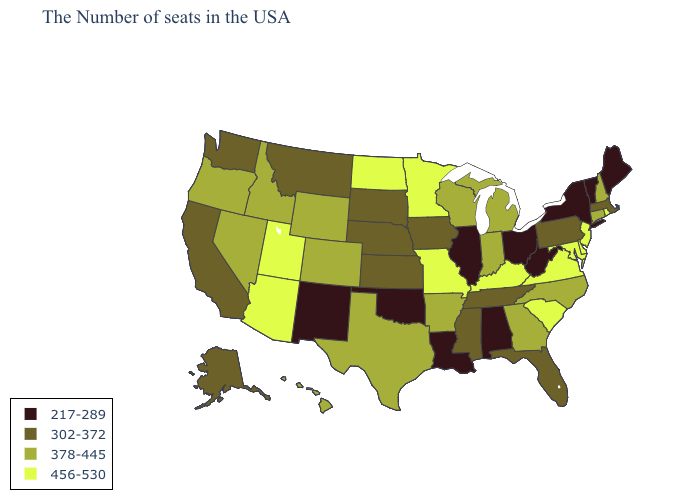Among the states that border South Carolina , which have the highest value?
Keep it brief. North Carolina, Georgia. What is the value of Oregon?
Write a very short answer. 378-445. Name the states that have a value in the range 302-372?
Short answer required. Massachusetts, Pennsylvania, Florida, Tennessee, Mississippi, Iowa, Kansas, Nebraska, South Dakota, Montana, California, Washington, Alaska. Which states have the highest value in the USA?
Short answer required. Rhode Island, New Jersey, Delaware, Maryland, Virginia, South Carolina, Kentucky, Missouri, Minnesota, North Dakota, Utah, Arizona. Does Missouri have the highest value in the USA?
Give a very brief answer. Yes. What is the value of Tennessee?
Give a very brief answer. 302-372. What is the value of California?
Write a very short answer. 302-372. Name the states that have a value in the range 378-445?
Give a very brief answer. New Hampshire, Connecticut, North Carolina, Georgia, Michigan, Indiana, Wisconsin, Arkansas, Texas, Wyoming, Colorado, Idaho, Nevada, Oregon, Hawaii. Does the map have missing data?
Short answer required. No. What is the value of Washington?
Quick response, please. 302-372. Name the states that have a value in the range 456-530?
Write a very short answer. Rhode Island, New Jersey, Delaware, Maryland, Virginia, South Carolina, Kentucky, Missouri, Minnesota, North Dakota, Utah, Arizona. Which states have the highest value in the USA?
Short answer required. Rhode Island, New Jersey, Delaware, Maryland, Virginia, South Carolina, Kentucky, Missouri, Minnesota, North Dakota, Utah, Arizona. What is the value of Illinois?
Quick response, please. 217-289. Does the first symbol in the legend represent the smallest category?
Answer briefly. Yes. Which states have the lowest value in the West?
Concise answer only. New Mexico. 